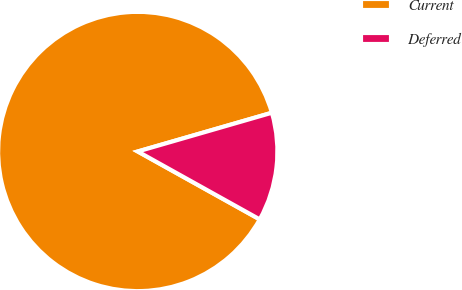Convert chart to OTSL. <chart><loc_0><loc_0><loc_500><loc_500><pie_chart><fcel>Current<fcel>Deferred<nl><fcel>87.44%<fcel>12.56%<nl></chart> 